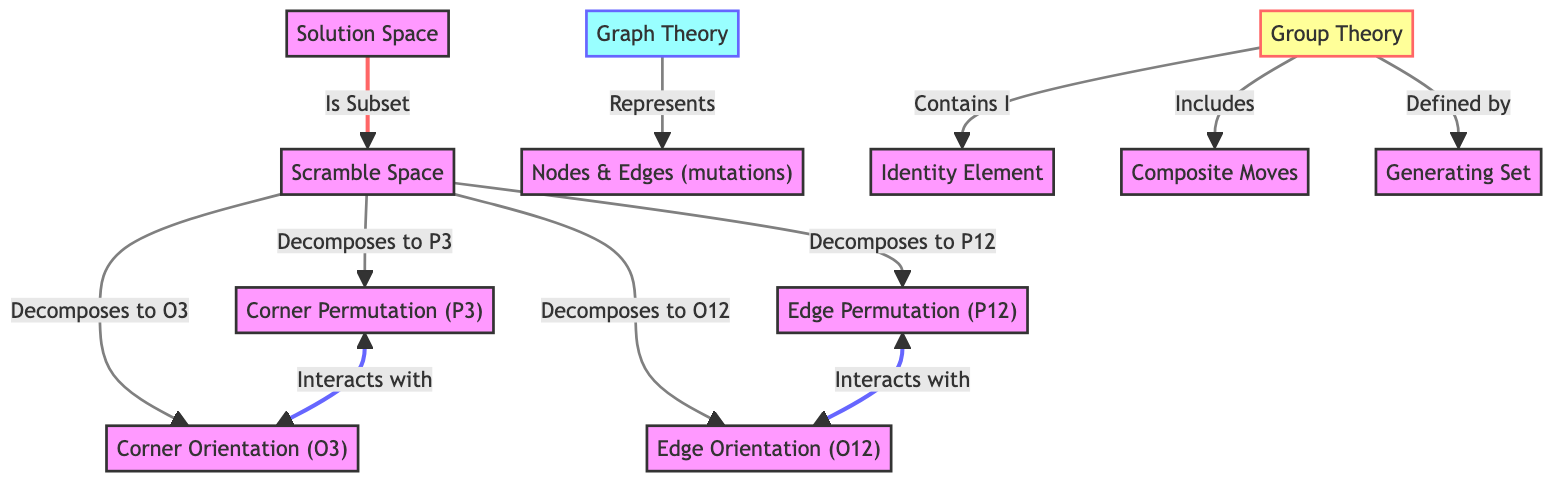What's the number of nodes in the diagram? The diagram contains a total of 10 nodes, including "Scramble Space," "Solution Space," "Corner Permutation," "Corner Orientation," "Edge Permutation," "Edge Orientation," "Graph Theory," "Group Theory," "Identity Element," and "Composite Moves." Each of these represents distinct concepts or groups in the mathematical representation of the Rubik's Cube.
Answer: 10 Which node interacts with edge orientation? The node "Edge Permutation" directly interacts with "Edge Orientation," as indicated by the double-headed arrow connecting the two, which signifies a mutual relationship between them.
Answer: Edge Permutation What concept does the scramble space decompose into? The scramble space decomposes into four components: "Corner Permutation," "Corner Orientation," "Edge Permutation," and "Edge Orientation," each representing specific attributes of the cube's state.
Answer: Corner Permutation, Corner Orientation, Edge Permutation, Edge Orientation What classification does graph theory fall under in the diagram? In the diagram, "Graph Theory" is classified as a specific concept related to the representation of nodes and edges, particularly in the context of mutations connecting different states of the cube.
Answer: Graph Theory Which element is contained within the group theory node? The "Identity Element" is contained within the "Group Theory" node, which is fundamental in understanding how moves and states relate under group operations in the context of the Rubik's Cube.
Answer: Identity Element How does the solution space relate to the scramble space? The solution space is described as a subset of the scramble space, meaning all valid solutions can be found within the broader set of scrambled configurations of the cube.
Answer: Subset What are composite moves in the context of group theory? "Composite Moves" are part of the "Group Theory" node and represent a collection of multiple moves combined together, showcasing how different operations can yield new configurations.
Answer: Composite Moves What is the relationship between corner permutation and corner orientation? The relationship is an interactive one, as indicated by the bidirectional arrow, which suggests that changes in corner permutation affect corner orientation and vice versa.
Answer: Interacts with What defines the group theory in the diagram? The "Generating Set" is identified as defining "Group Theory," indicating that it is a fundamental component used to construct all possible moves of the cube from a base set of operations.
Answer: Generating Set 